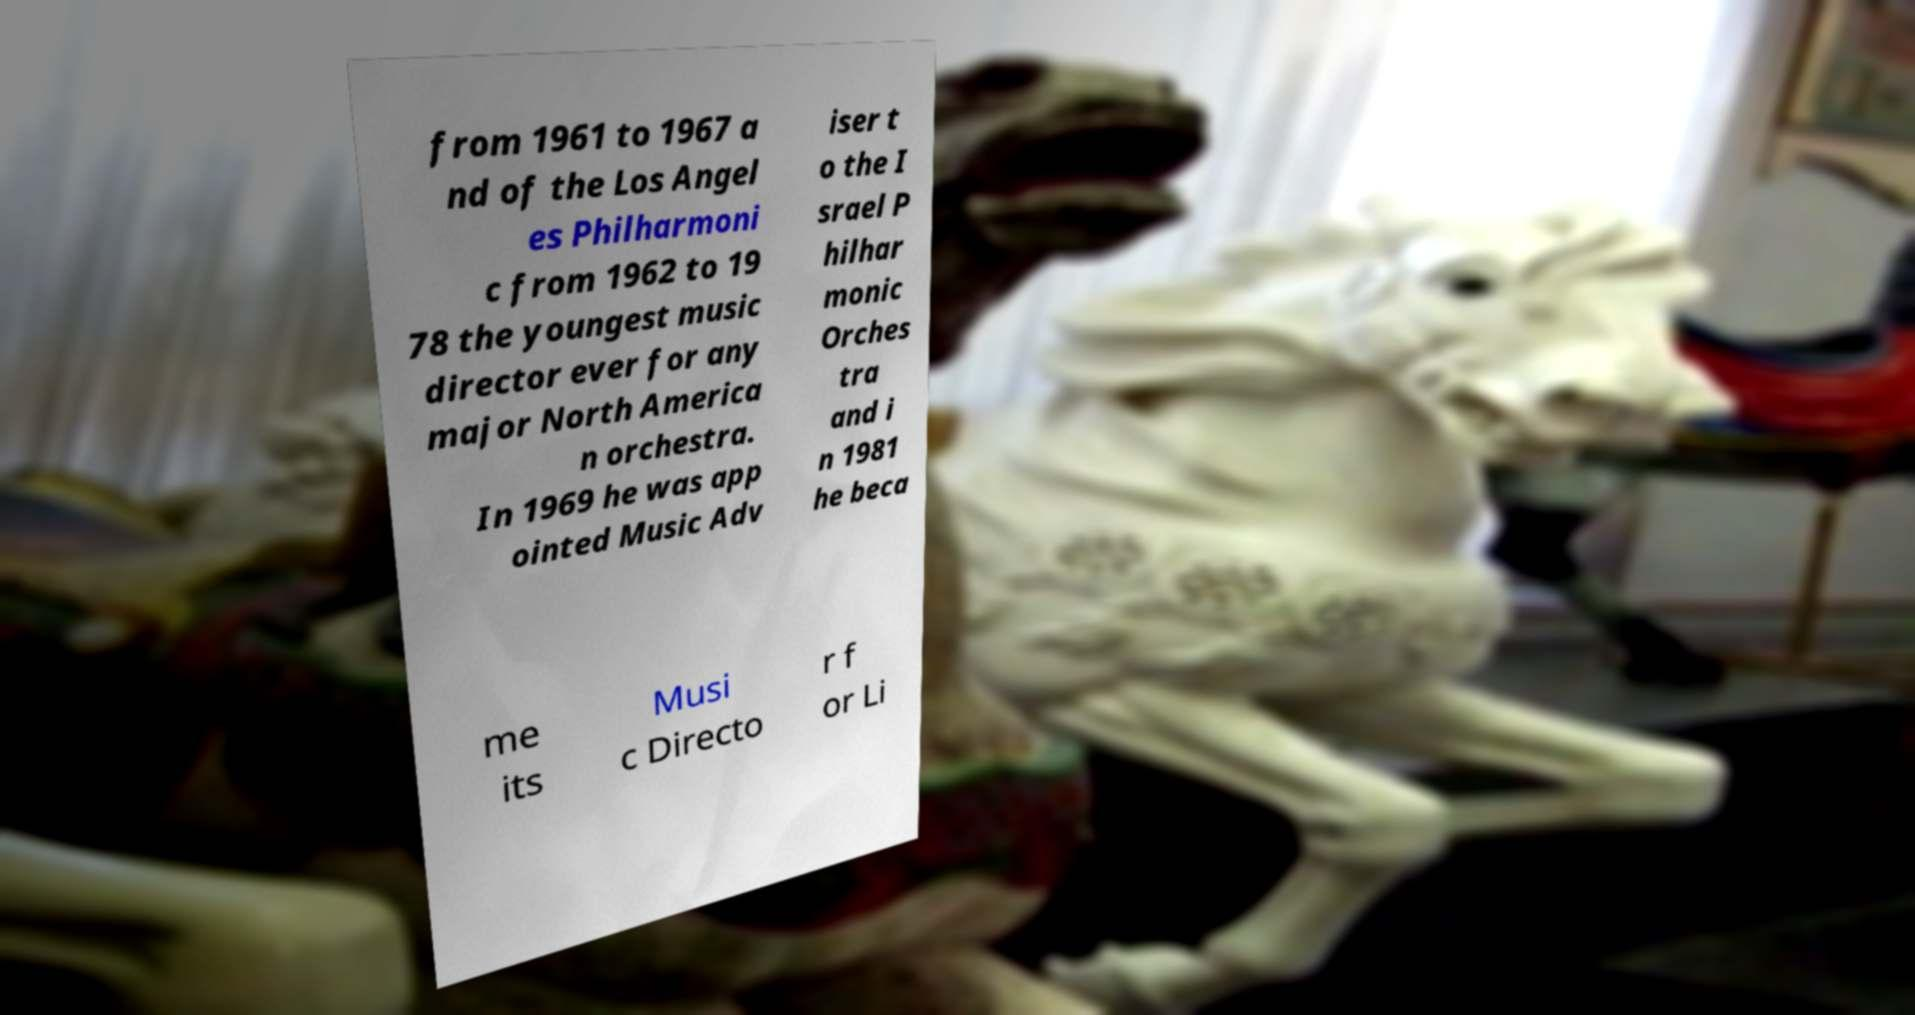Please read and relay the text visible in this image. What does it say? from 1961 to 1967 a nd of the Los Angel es Philharmoni c from 1962 to 19 78 the youngest music director ever for any major North America n orchestra. In 1969 he was app ointed Music Adv iser t o the I srael P hilhar monic Orches tra and i n 1981 he beca me its Musi c Directo r f or Li 